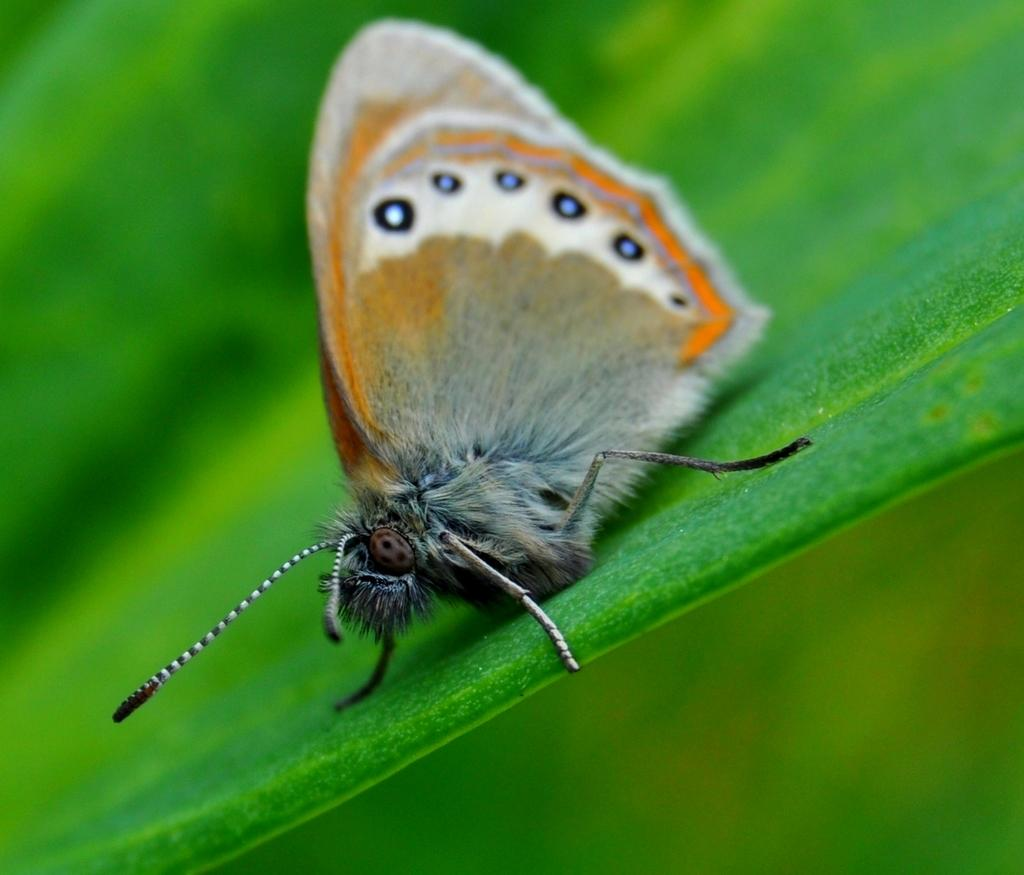What is the main subject of the image? There is a butterfly in the image. Where is the butterfly located? The butterfly is on a leaf. What type of instrument is the butterfly playing in the image? There is no instrument present in the image, and the butterfly is not playing any instrument. 